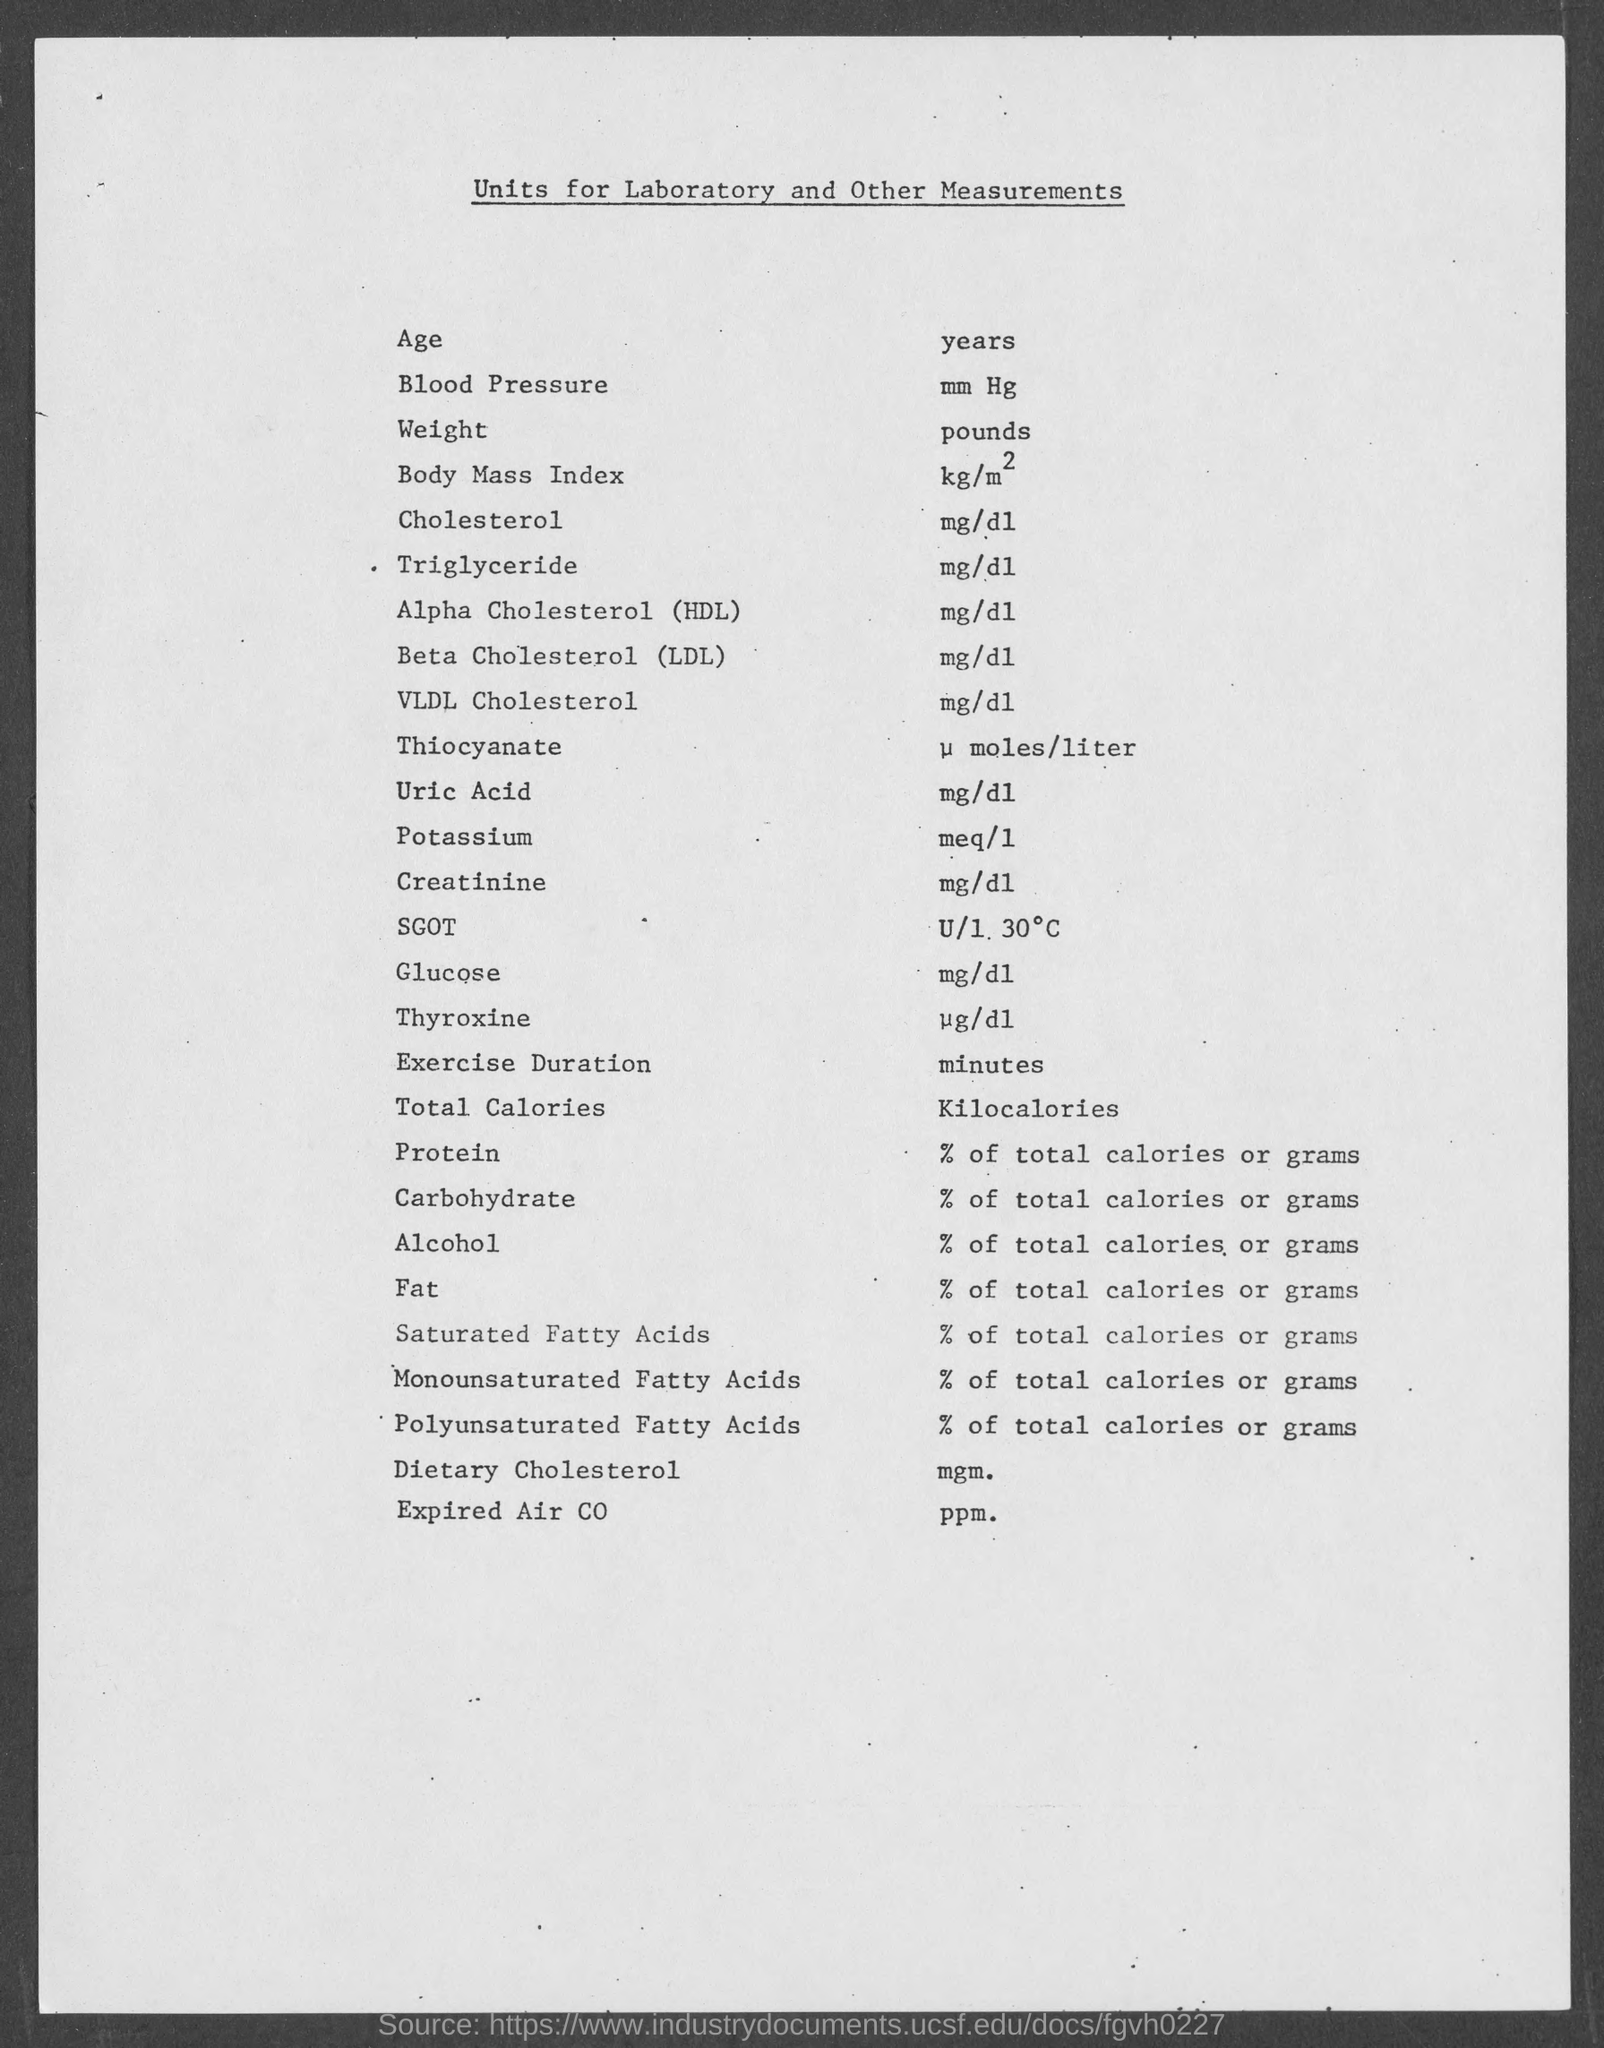Point out several critical features in this image. The unit of measurement for glucose is milligrams per deciliter (mg/dL). The unit of measurement for carbohydrates is either % of total calories or grams. The unit of age given in the document is years. This document contains the title and units for laboratory and other measurements. Blood pressure is measured in millimeters of mercury (mm Hg). 